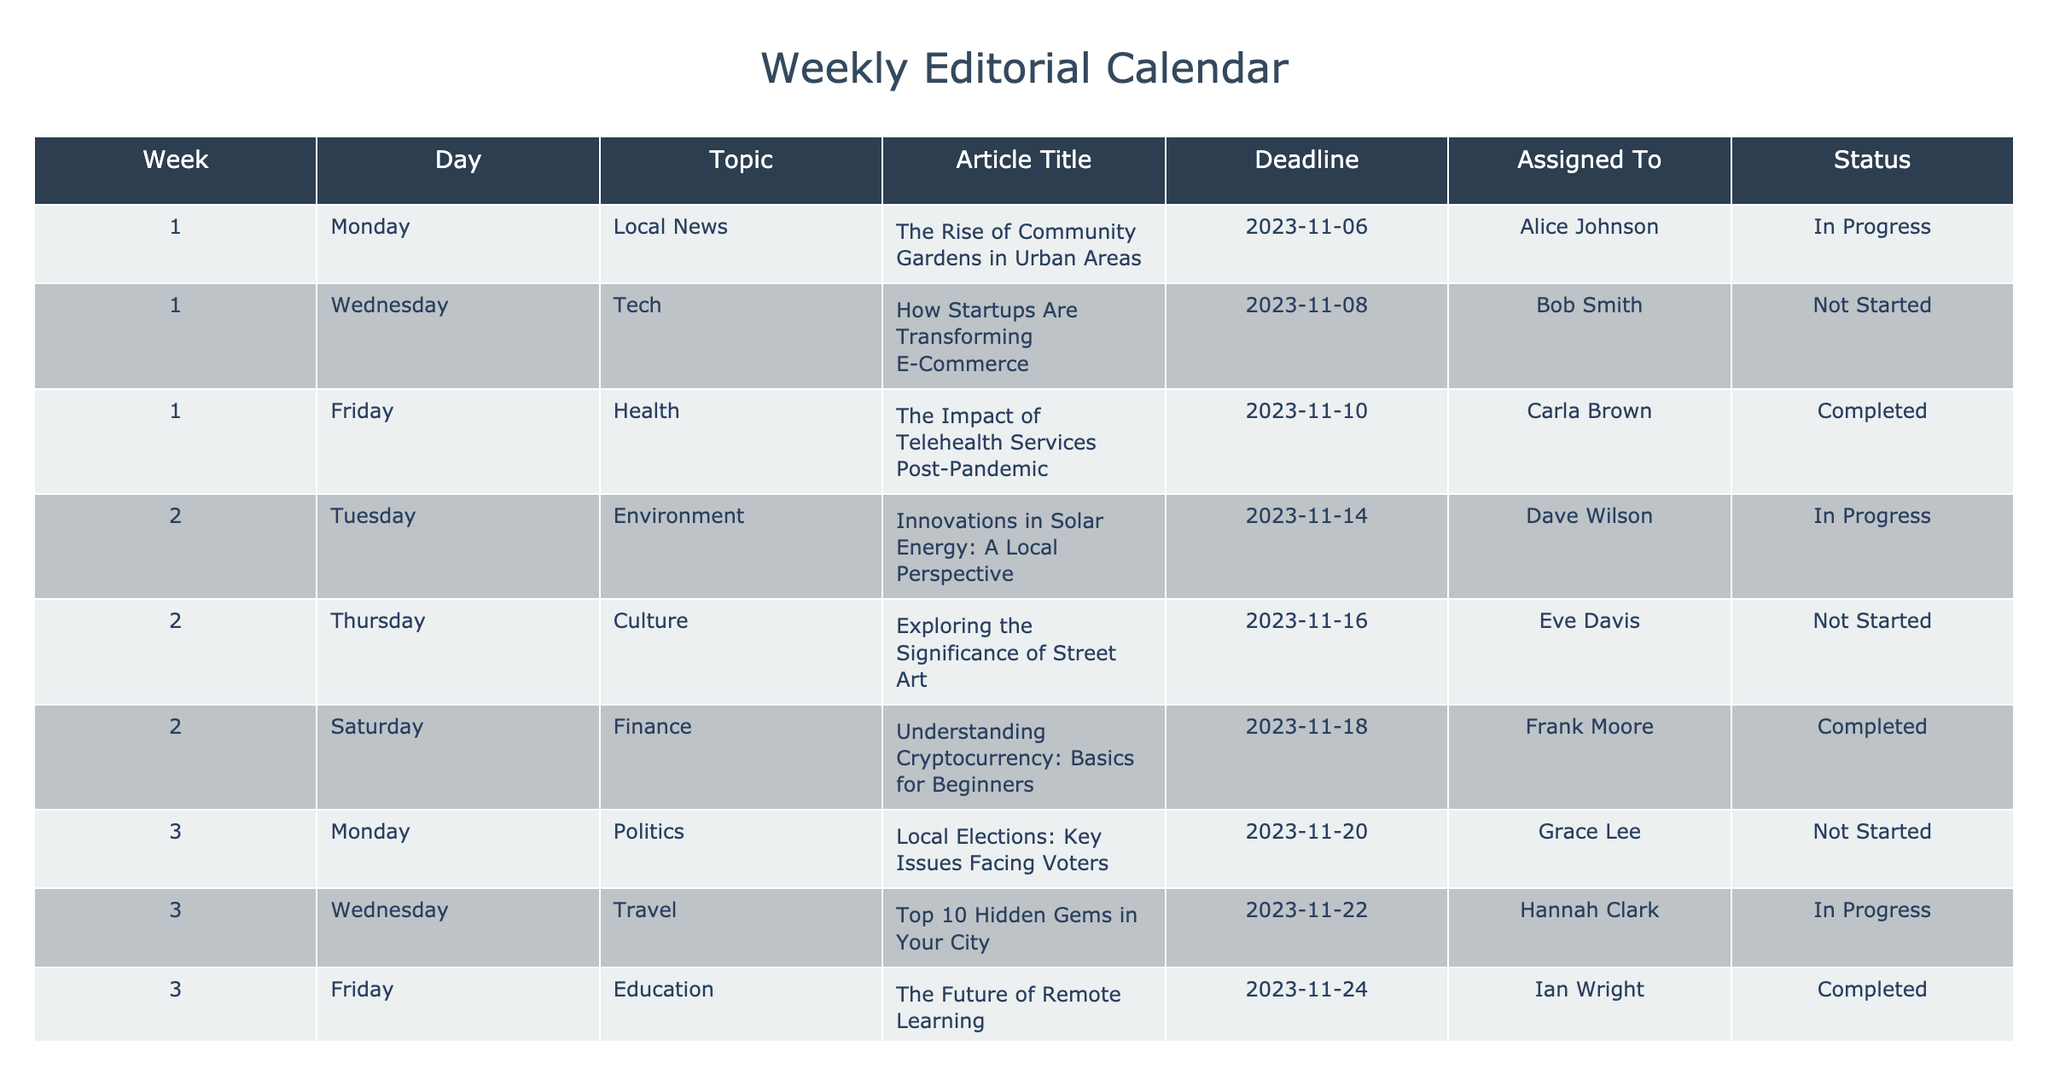What is the article title for the piece assigned to Alice Johnson? To find the article title assigned to Alice Johnson, I look at the "Assigned To" column and identify her name. She is listed in Week 1, Monday, which has the topic "Local News". The corresponding article title is "The Rise of Community Gardens in Urban Areas".
Answer: The Rise of Community Gardens in Urban Areas How many articles are currently marked as "In Progress"? I will count the number of rows in the table where the "Status" column is "In Progress". Checking through the table, I find that there are three articles with this status: the one assigned to Alice Johnson, the one assigned to Dave Wilson, and the one assigned to Kevin White.
Answer: 3 Is there any article scheduled for a Saturday? To answer this, I will check the "Day" column for any instances of "Saturday". Scanning through the table, I find that there are two articles scheduled for Saturday: "Understanding Cryptocurrency: Basics for Beginners" and "The Importance of Local Journalism in 2023". Hence, there are articles scheduled for Saturday.
Answer: Yes What is the deadline for the article about "The Future of Remote Learning"? I will locate the article with the title "The Future of Remote Learning" in the table. It is associated with Ian Wright, and upon finding the correct row, I can see that the deadline is listed as "2023-11-24".
Answer: 2023-11-24 What is the average number of days between deadlines for articles scheduled in Week 2 and Week 3? To find the average number of days between deadlines, I first note the deadlines for Week 2 (2023-11-14, 2023-11-16, 2023-11-18) and Week 3 (2023-11-20, 2023-11-22, 2023-11-24). Calculating the differences: 2023-11-14 to 2023-11-20 is 6 days, 2023-11-16 to 2023-11-22 is 6 days, and 2023-11-18 to 2023-11-24 is also 6 days. The total is 6 + 6 + 6 = 18 days, and there are 3 intervals, so the average is 18 / 3 = 6 days.
Answer: 6 days 